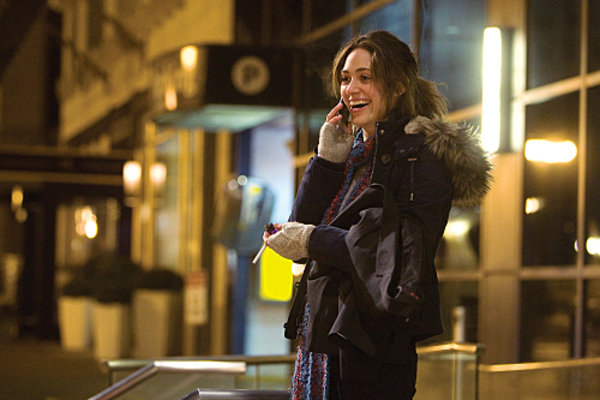Describe how the lighting affects the mood of this scene. The lighting in the scene plays a significant role in setting an intimate and warm mood despite the urban environment. The soft glow from the streetlamp and the illuminated signage nearby cast a gentle light on her, enhancing her cheerful demeanor and creating a contrast with the darker, colder night around her. 